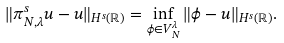Convert formula to latex. <formula><loc_0><loc_0><loc_500><loc_500>\| \pi _ { N , \lambda } ^ { s } u - u \| _ { H ^ { s } ( \mathbb { R } ) } = \inf _ { \phi \in V _ { N } ^ { \lambda } } \| \phi - u \| _ { H ^ { s } ( \mathbb { R } ) } .</formula> 